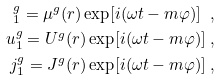Convert formula to latex. <formula><loc_0><loc_0><loc_500><loc_500>_ { 1 } ^ { g } = \mu ^ { g } ( r ) \exp [ i ( \omega t - m \varphi ) ] \ , \\ u _ { 1 } ^ { g } = U ^ { g } ( r ) \exp [ i ( \omega t - m \varphi ) ] \ , \\ j _ { 1 } ^ { g } = J ^ { g } ( r ) \exp [ i ( \omega t - m \varphi ) ] \ ,</formula> 